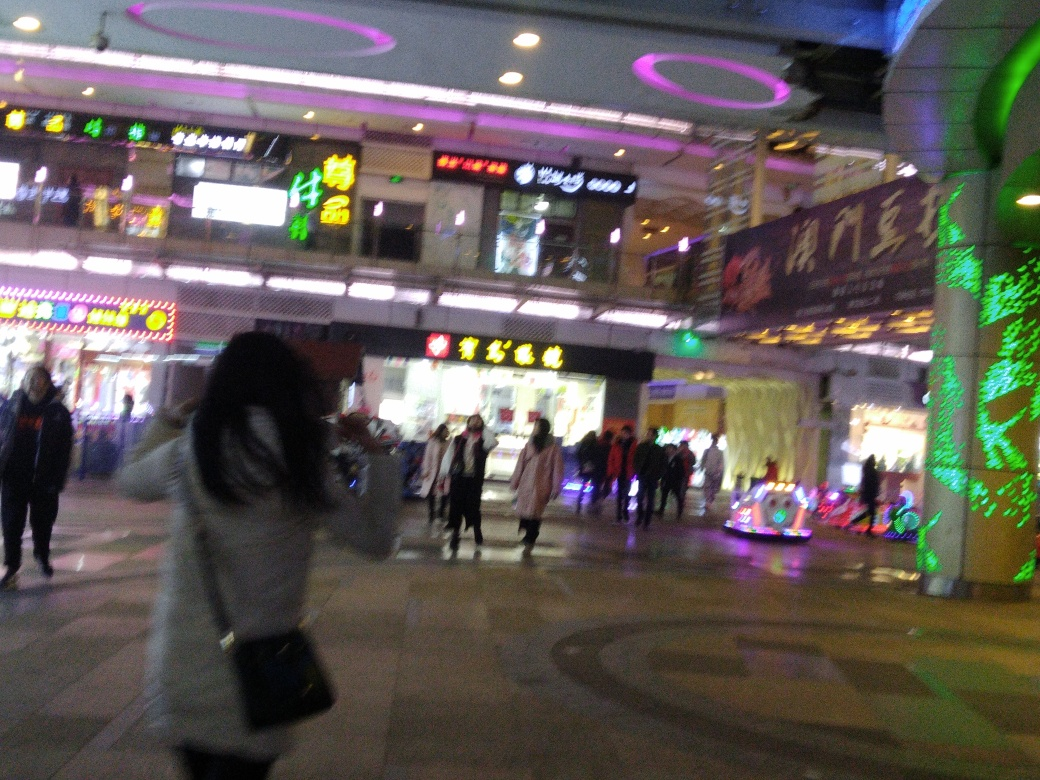Are the main subjects in the image blurry?
A. Yes
B. No
Answer with the option's letter from the given choices directly.
 A. 